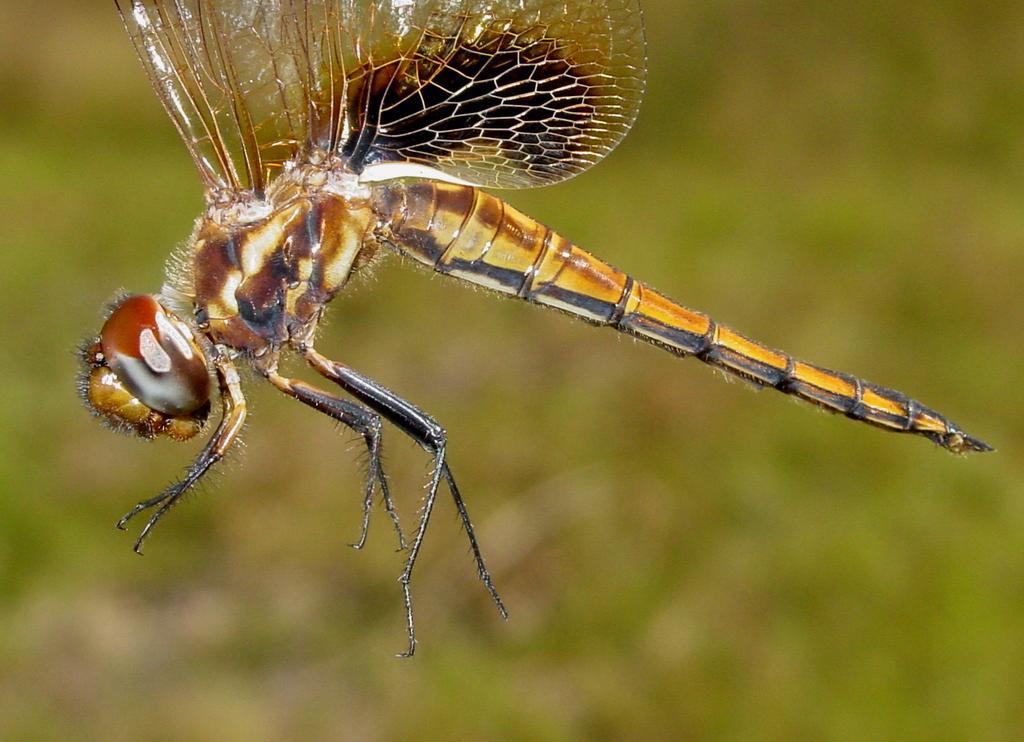Describe this image in one or two sentences. In this image we can see an insect and a blurry background. 